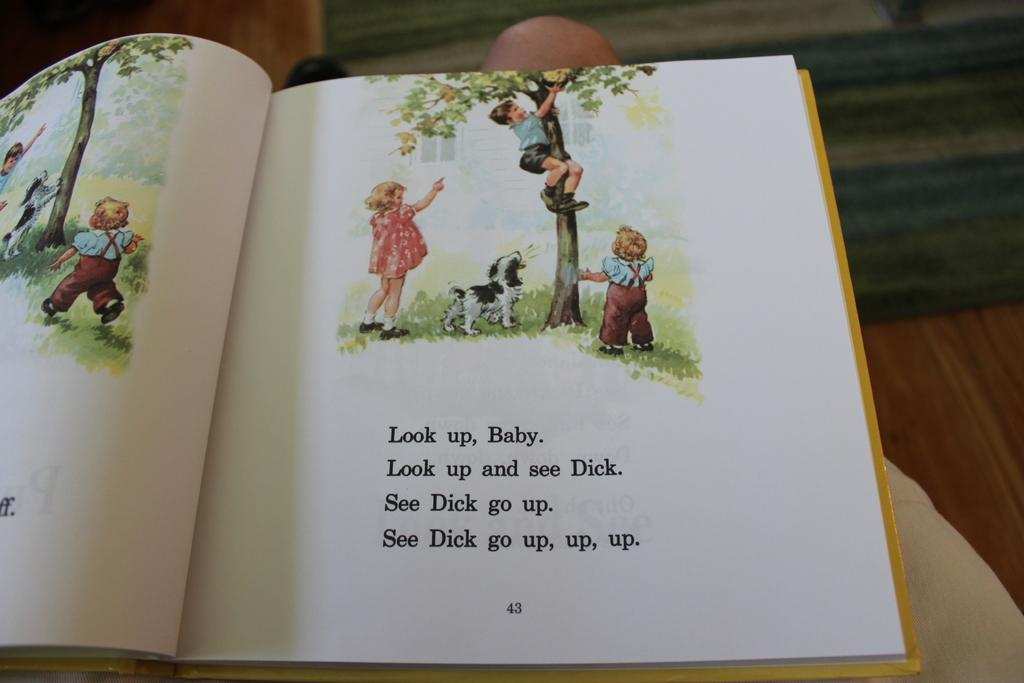<image>
Summarize the visual content of the image. Page 43 of a book showing a little boy climbing a tree. 